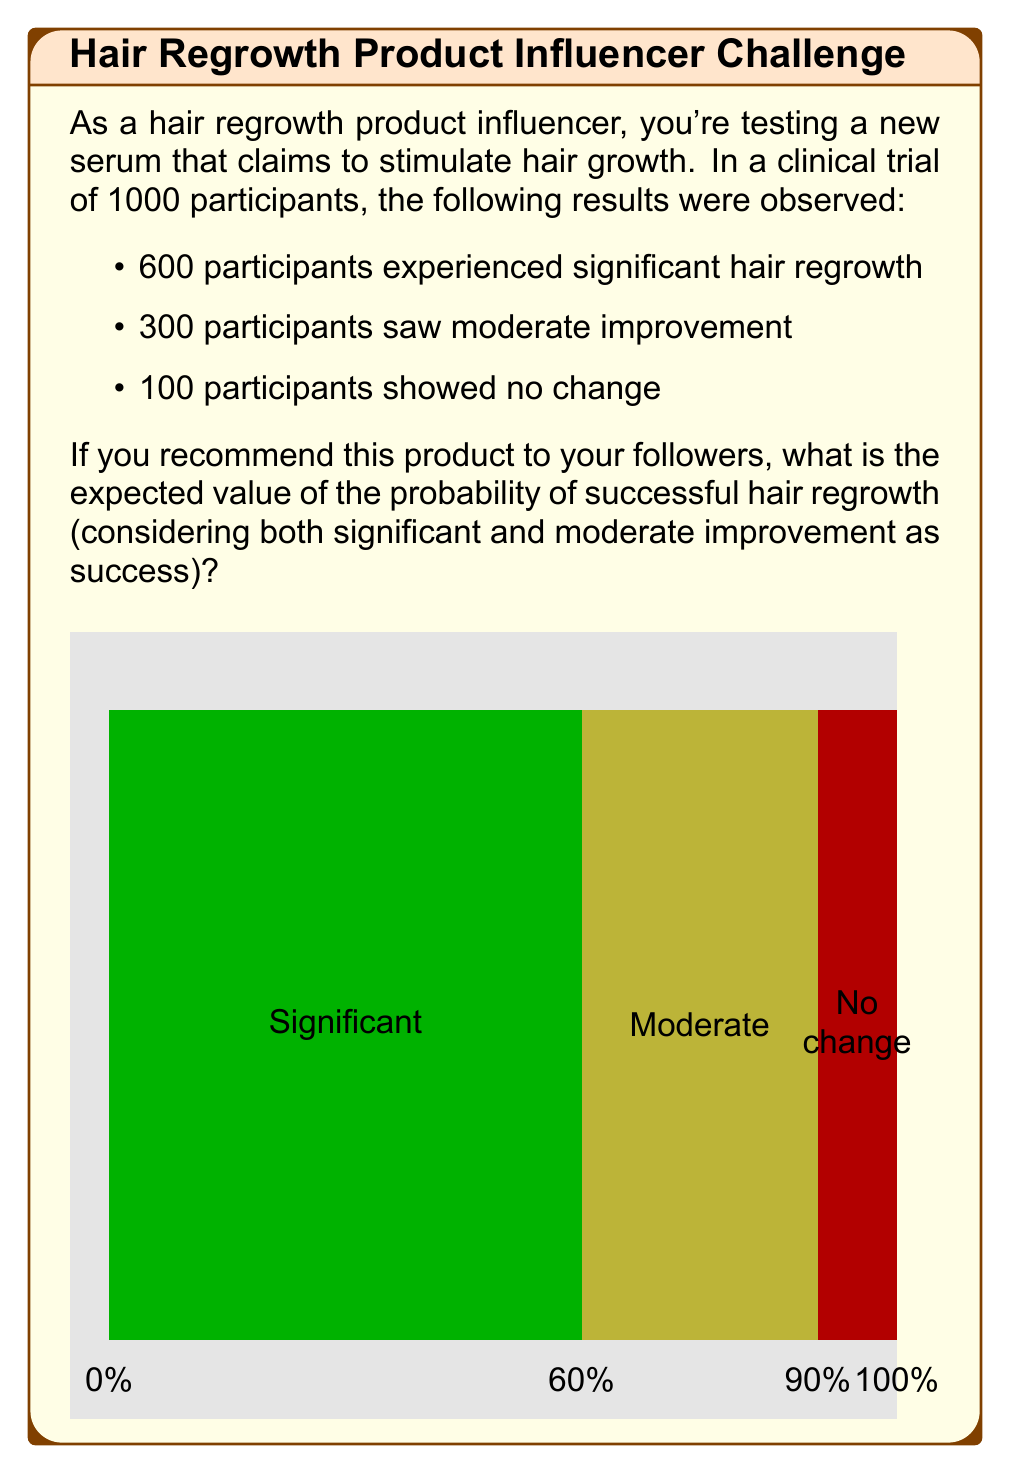Show me your answer to this math problem. Let's break this down step-by-step:

1) First, we need to define success. In this case, success is either significant or moderate improvement.

2) To calculate the probability of success, we add the number of participants who experienced significant and moderate improvement:

   $600 + 300 = 900$ successful cases

3) The total number of participants is 1000.

4) The probability of success is therefore:

   $$P(\text{success}) = \frac{\text{number of successful cases}}{\text{total number of cases}} = \frac{900}{1000} = 0.9$$

5) In probability theory, the expected value is equal to the probability of an event occurring when there's only one trial.

6) Therefore, the expected value of the probability of successful hair regrowth is:

   $$E(\text{successful hair regrowth}) = P(\text{success}) = 0.9$$

This means that if you recommend this product to your followers, there's a 90% chance (or 0.9 probability) that they will experience either significant or moderate hair regrowth.
Answer: $0.9$ 